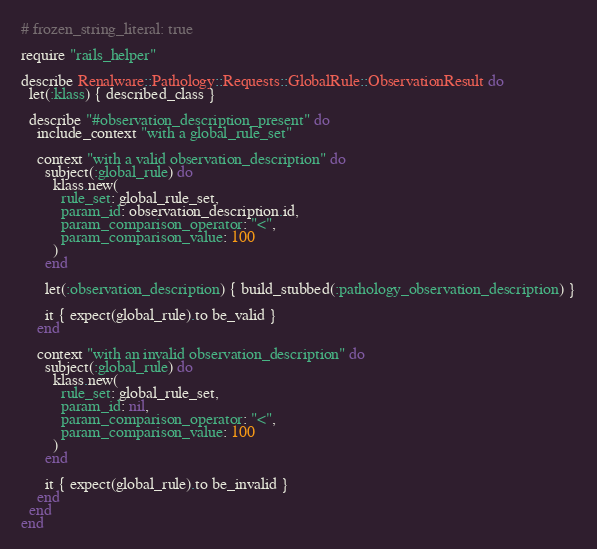<code> <loc_0><loc_0><loc_500><loc_500><_Ruby_># frozen_string_literal: true

require "rails_helper"

describe Renalware::Pathology::Requests::GlobalRule::ObservationResult do
  let(:klass) { described_class }

  describe "#observation_description_present" do
    include_context "with a global_rule_set"

    context "with a valid observation_description" do
      subject(:global_rule) do
        klass.new(
          rule_set: global_rule_set,
          param_id: observation_description.id,
          param_comparison_operator: "<",
          param_comparison_value: 100
        )
      end

      let(:observation_description) { build_stubbed(:pathology_observation_description) }

      it { expect(global_rule).to be_valid }
    end

    context "with an invalid observation_description" do
      subject(:global_rule) do
        klass.new(
          rule_set: global_rule_set,
          param_id: nil,
          param_comparison_operator: "<",
          param_comparison_value: 100
        )
      end

      it { expect(global_rule).to be_invalid }
    end
  end
end
</code> 